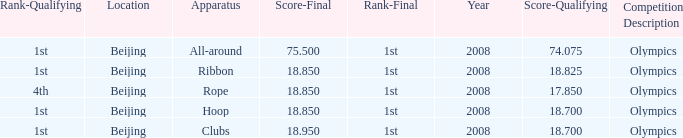What was her lowest final score with a qualifying score of 74.075? 75.5. 